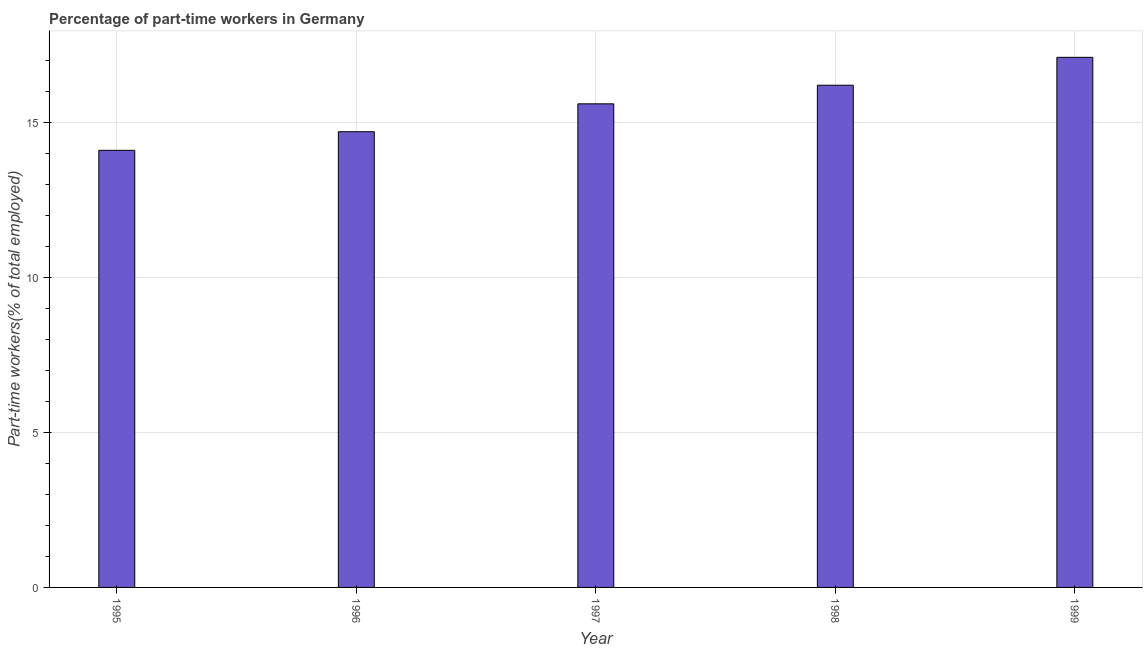Does the graph contain any zero values?
Offer a terse response. No. Does the graph contain grids?
Offer a terse response. Yes. What is the title of the graph?
Provide a succinct answer. Percentage of part-time workers in Germany. What is the label or title of the Y-axis?
Keep it short and to the point. Part-time workers(% of total employed). What is the percentage of part-time workers in 1999?
Ensure brevity in your answer.  17.1. Across all years, what is the maximum percentage of part-time workers?
Keep it short and to the point. 17.1. Across all years, what is the minimum percentage of part-time workers?
Your answer should be compact. 14.1. In which year was the percentage of part-time workers maximum?
Provide a succinct answer. 1999. What is the sum of the percentage of part-time workers?
Keep it short and to the point. 77.7. What is the difference between the percentage of part-time workers in 1997 and 1999?
Make the answer very short. -1.5. What is the average percentage of part-time workers per year?
Your answer should be very brief. 15.54. What is the median percentage of part-time workers?
Make the answer very short. 15.6. Do a majority of the years between 1998 and 1997 (inclusive) have percentage of part-time workers greater than 1 %?
Offer a terse response. No. What is the ratio of the percentage of part-time workers in 1995 to that in 1999?
Your answer should be very brief. 0.82. Is the sum of the percentage of part-time workers in 1996 and 1998 greater than the maximum percentage of part-time workers across all years?
Offer a very short reply. Yes. In how many years, is the percentage of part-time workers greater than the average percentage of part-time workers taken over all years?
Give a very brief answer. 3. How many years are there in the graph?
Your response must be concise. 5. Are the values on the major ticks of Y-axis written in scientific E-notation?
Your answer should be very brief. No. What is the Part-time workers(% of total employed) in 1995?
Provide a succinct answer. 14.1. What is the Part-time workers(% of total employed) in 1996?
Ensure brevity in your answer.  14.7. What is the Part-time workers(% of total employed) of 1997?
Make the answer very short. 15.6. What is the Part-time workers(% of total employed) of 1998?
Offer a very short reply. 16.2. What is the Part-time workers(% of total employed) of 1999?
Your answer should be compact. 17.1. What is the difference between the Part-time workers(% of total employed) in 1995 and 1998?
Make the answer very short. -2.1. What is the difference between the Part-time workers(% of total employed) in 1996 and 1999?
Provide a short and direct response. -2.4. What is the difference between the Part-time workers(% of total employed) in 1997 and 1998?
Your answer should be compact. -0.6. What is the difference between the Part-time workers(% of total employed) in 1997 and 1999?
Offer a very short reply. -1.5. What is the difference between the Part-time workers(% of total employed) in 1998 and 1999?
Keep it short and to the point. -0.9. What is the ratio of the Part-time workers(% of total employed) in 1995 to that in 1997?
Ensure brevity in your answer.  0.9. What is the ratio of the Part-time workers(% of total employed) in 1995 to that in 1998?
Your answer should be compact. 0.87. What is the ratio of the Part-time workers(% of total employed) in 1995 to that in 1999?
Offer a terse response. 0.82. What is the ratio of the Part-time workers(% of total employed) in 1996 to that in 1997?
Provide a short and direct response. 0.94. What is the ratio of the Part-time workers(% of total employed) in 1996 to that in 1998?
Your answer should be compact. 0.91. What is the ratio of the Part-time workers(% of total employed) in 1996 to that in 1999?
Ensure brevity in your answer.  0.86. What is the ratio of the Part-time workers(% of total employed) in 1997 to that in 1999?
Offer a very short reply. 0.91. What is the ratio of the Part-time workers(% of total employed) in 1998 to that in 1999?
Ensure brevity in your answer.  0.95. 